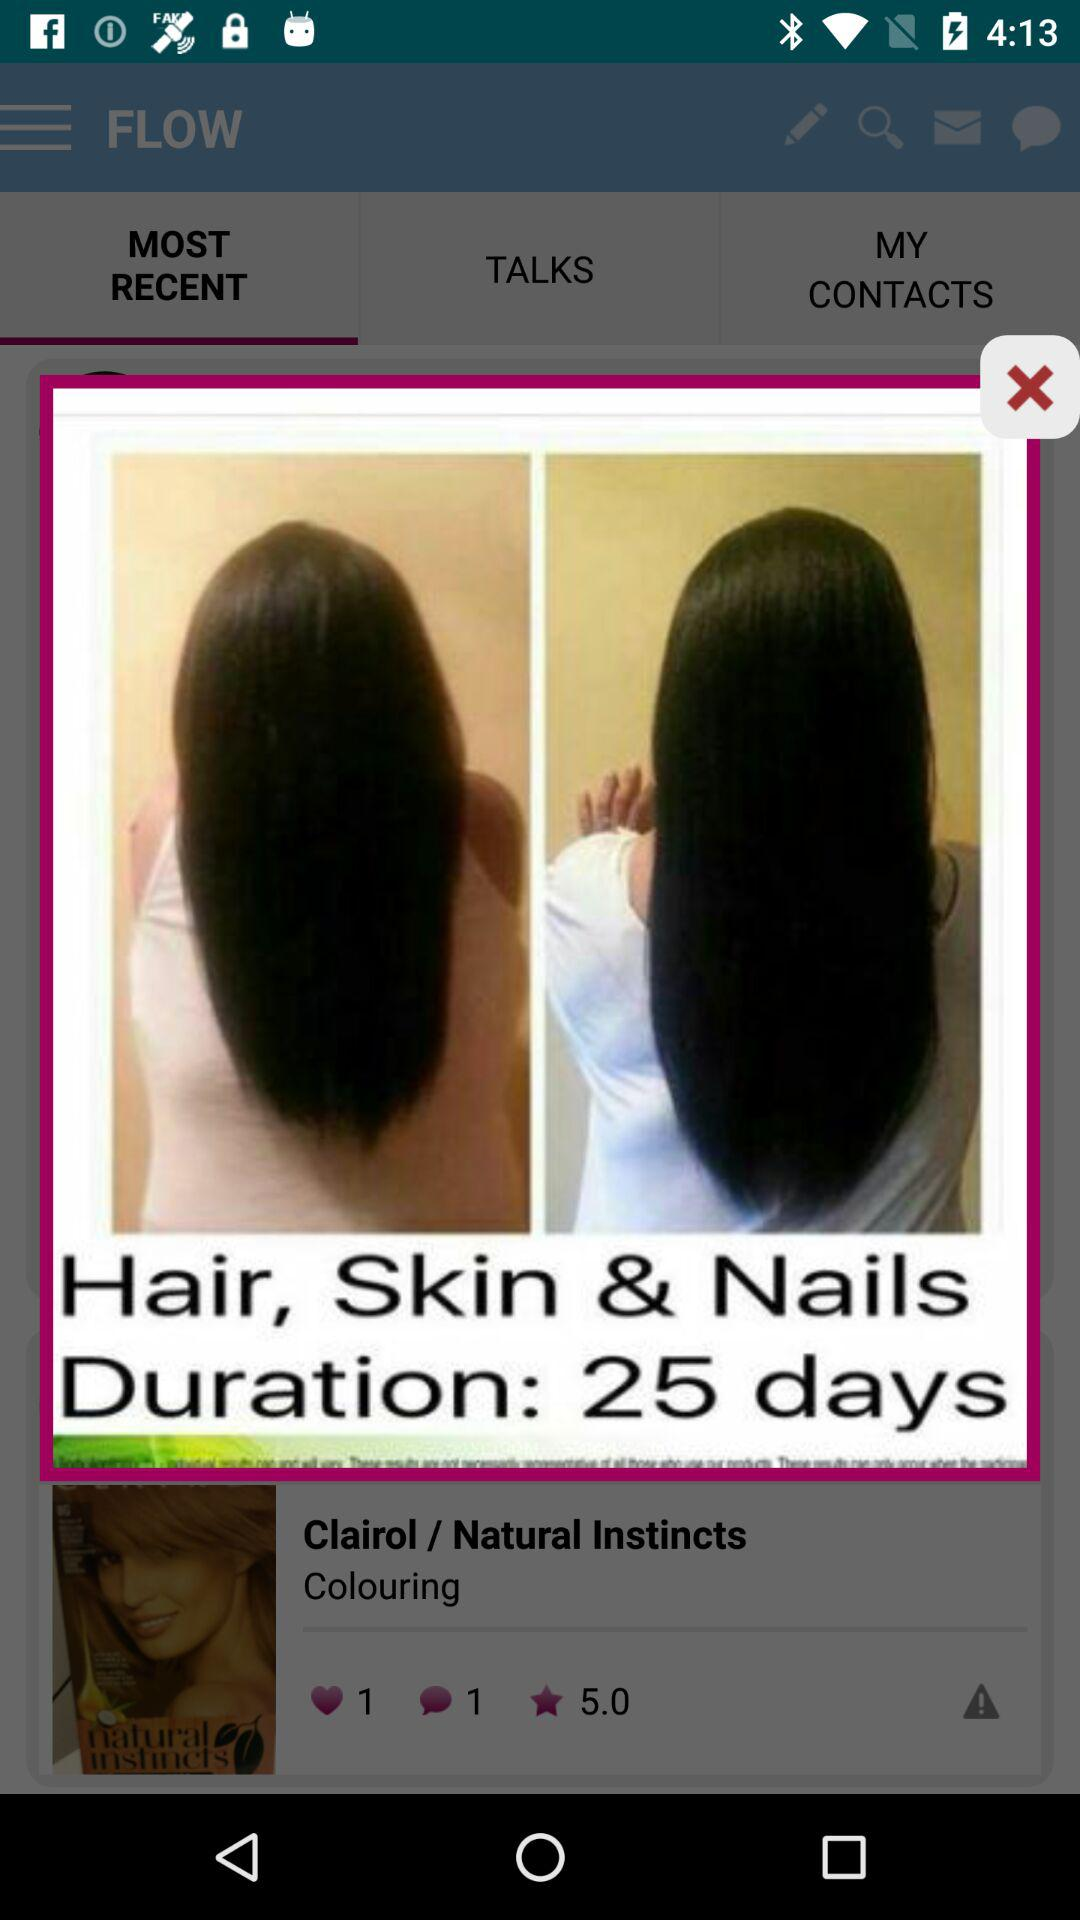What is the given duration? The given duration is 25 days. 